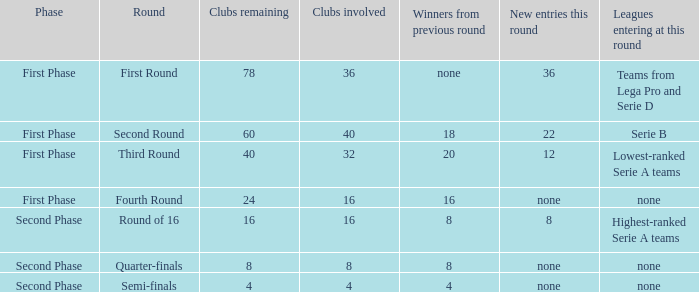Write the full table. {'header': ['Phase', 'Round', 'Clubs remaining', 'Clubs involved', 'Winners from previous round', 'New entries this round', 'Leagues entering at this round'], 'rows': [['First Phase', 'First Round', '78', '36', 'none', '36', 'Teams from Lega Pro and Serie D'], ['First Phase', 'Second Round', '60', '40', '18', '22', 'Serie B'], ['First Phase', 'Third Round', '40', '32', '20', '12', 'Lowest-ranked Serie A teams'], ['First Phase', 'Fourth Round', '24', '16', '16', 'none', 'none'], ['Second Phase', 'Round of 16', '16', '16', '8', '8', 'Highest-ranked Serie A teams'], ['Second Phase', 'Quarter-finals', '8', '8', '8', 'none', 'none'], ['Second Phase', 'Semi-finals', '4', '4', '4', 'none', 'none']]} During the first phase portion of phase and having 16 clubs involved; what would you find for the winners from previous round? 16.0. 